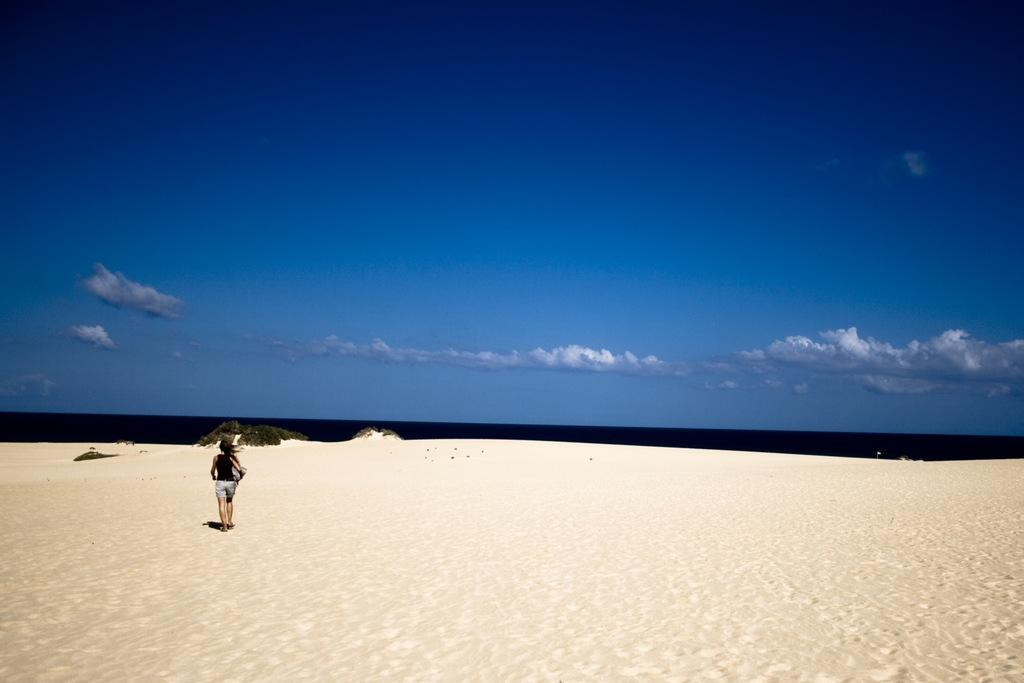What type of terrain is visible in the image? There is sand in the image. Who is present in the image? There is a woman in the image. What other natural elements can be seen in the image? There is grass and water visible in the image. What is visible in the background of the image? The sky is visible in the image, and there are clouds in the sky. What type of table is being used by the woman in the image? There is no table present in the image. What thrilling activity is the woman participating in while in the image? The image does not depict any specific activity, and there is no indication of a thrilling activity taking place. 